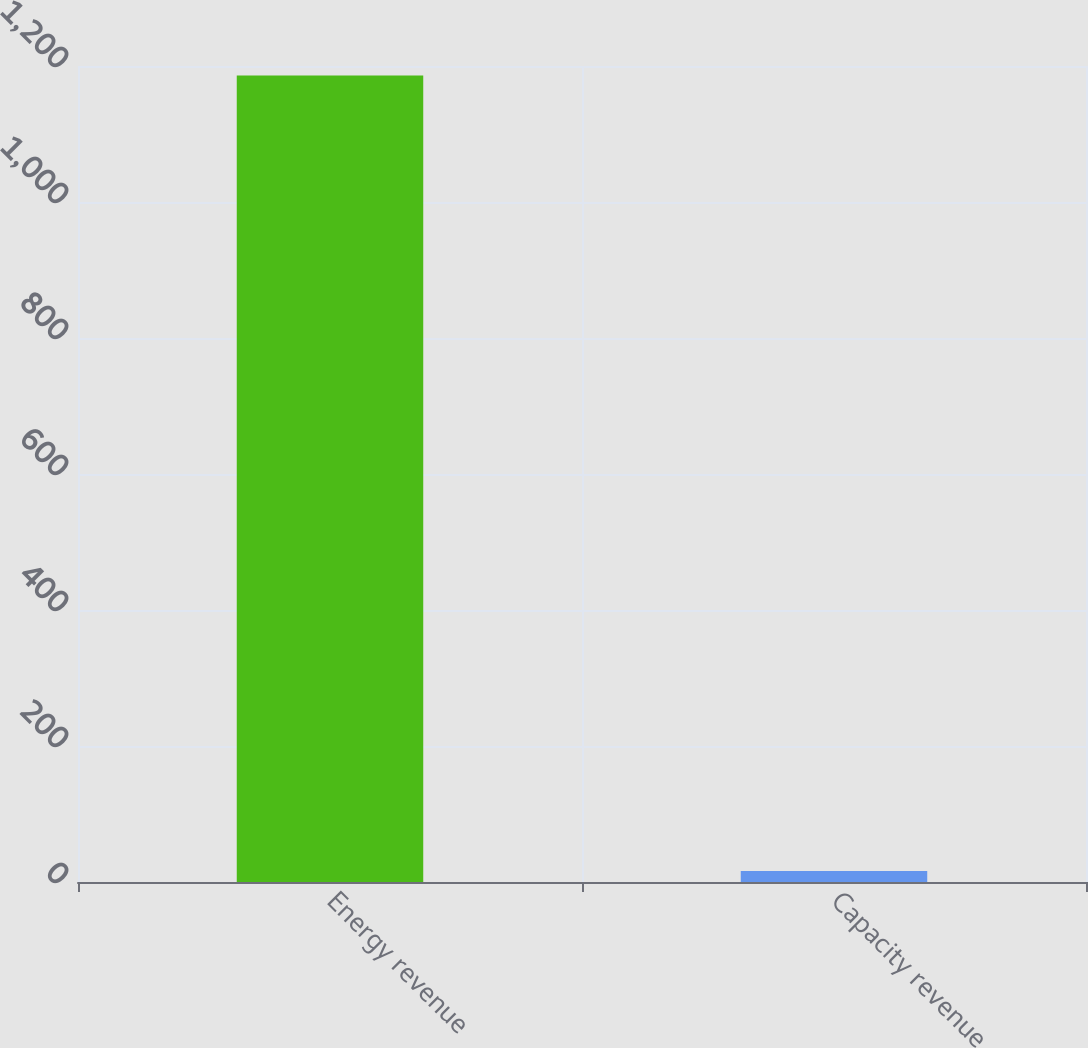<chart> <loc_0><loc_0><loc_500><loc_500><bar_chart><fcel>Energy revenue<fcel>Capacity revenue<nl><fcel>1186<fcel>16<nl></chart> 